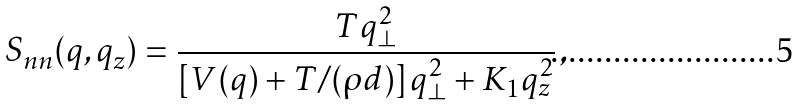<formula> <loc_0><loc_0><loc_500><loc_500>S _ { n n } ( { q } , q _ { z } ) = \frac { T q _ { \perp } ^ { 2 } } { \left [ V ( { q } ) + T / ( { \rho } d ) \right ] q _ { \perp } ^ { 2 } + K _ { 1 } q _ { z } ^ { 2 } } \, ,</formula> 